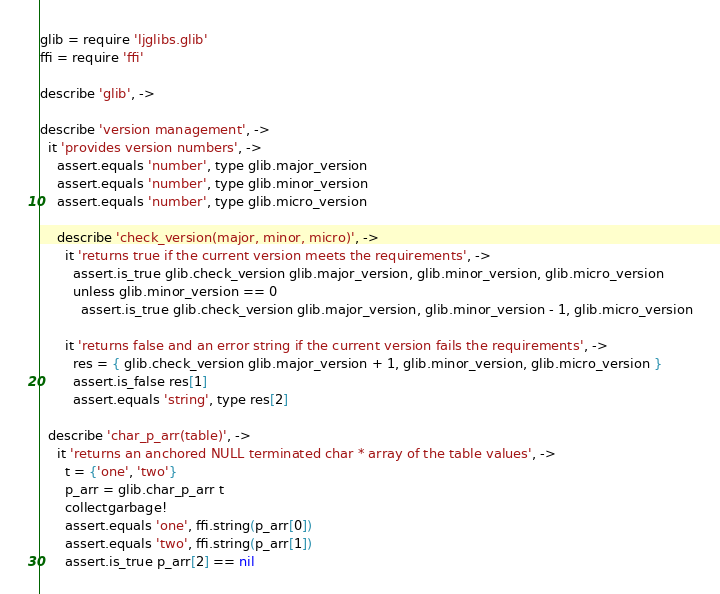<code> <loc_0><loc_0><loc_500><loc_500><_MoonScript_>glib = require 'ljglibs.glib'
ffi = require 'ffi'

describe 'glib', ->

describe 'version management', ->
  it 'provides version numbers', ->
    assert.equals 'number', type glib.major_version
    assert.equals 'number', type glib.minor_version
    assert.equals 'number', type glib.micro_version

    describe 'check_version(major, minor, micro)', ->
      it 'returns true if the current version meets the requirements', ->
        assert.is_true glib.check_version glib.major_version, glib.minor_version, glib.micro_version
        unless glib.minor_version == 0
          assert.is_true glib.check_version glib.major_version, glib.minor_version - 1, glib.micro_version

      it 'returns false and an error string if the current version fails the requirements', ->
        res = { glib.check_version glib.major_version + 1, glib.minor_version, glib.micro_version }
        assert.is_false res[1]
        assert.equals 'string', type res[2]

  describe 'char_p_arr(table)', ->
    it 'returns an anchored NULL terminated char * array of the table values', ->
      t = {'one', 'two'}
      p_arr = glib.char_p_arr t
      collectgarbage!
      assert.equals 'one', ffi.string(p_arr[0])
      assert.equals 'two', ffi.string(p_arr[1])
      assert.is_true p_arr[2] == nil
</code> 